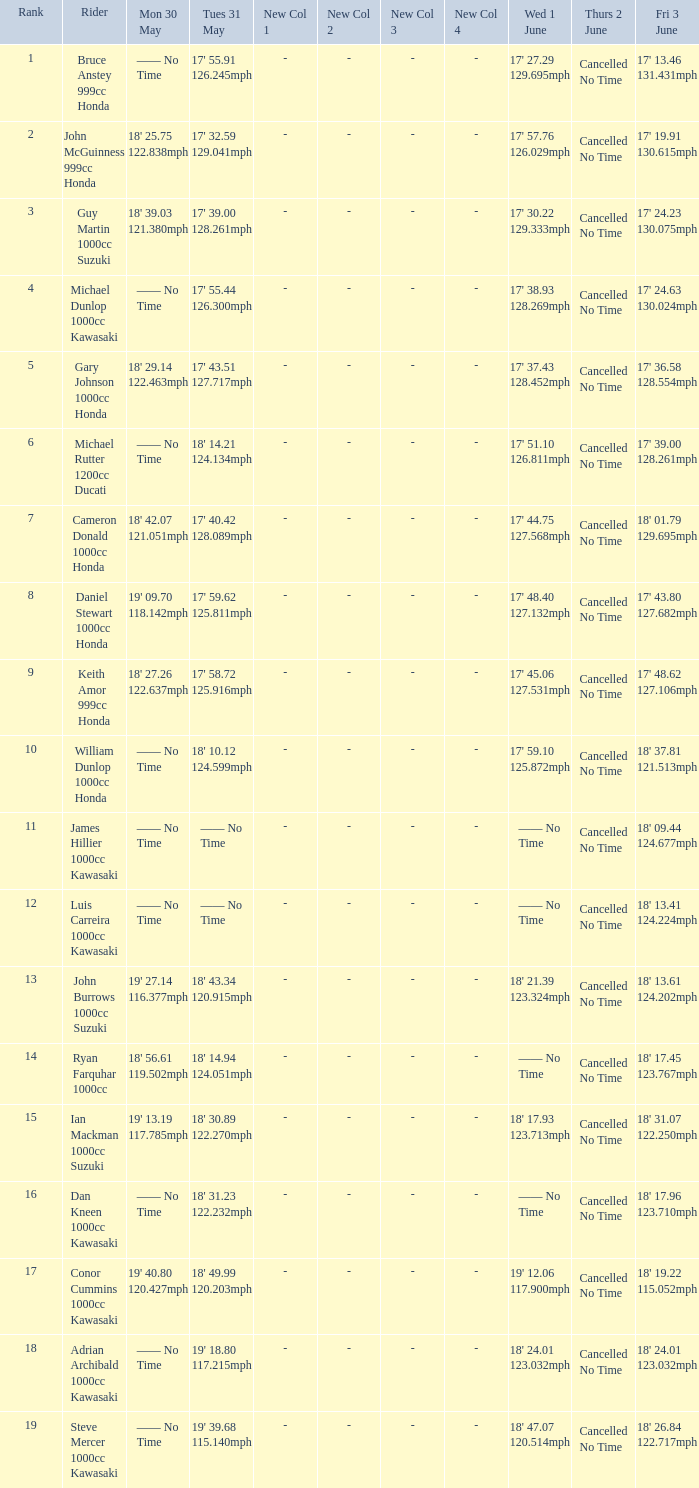What is the Thurs 2 June time for the rider with a Fri 3 June time of 17' 36.58 128.554mph? Cancelled No Time. 